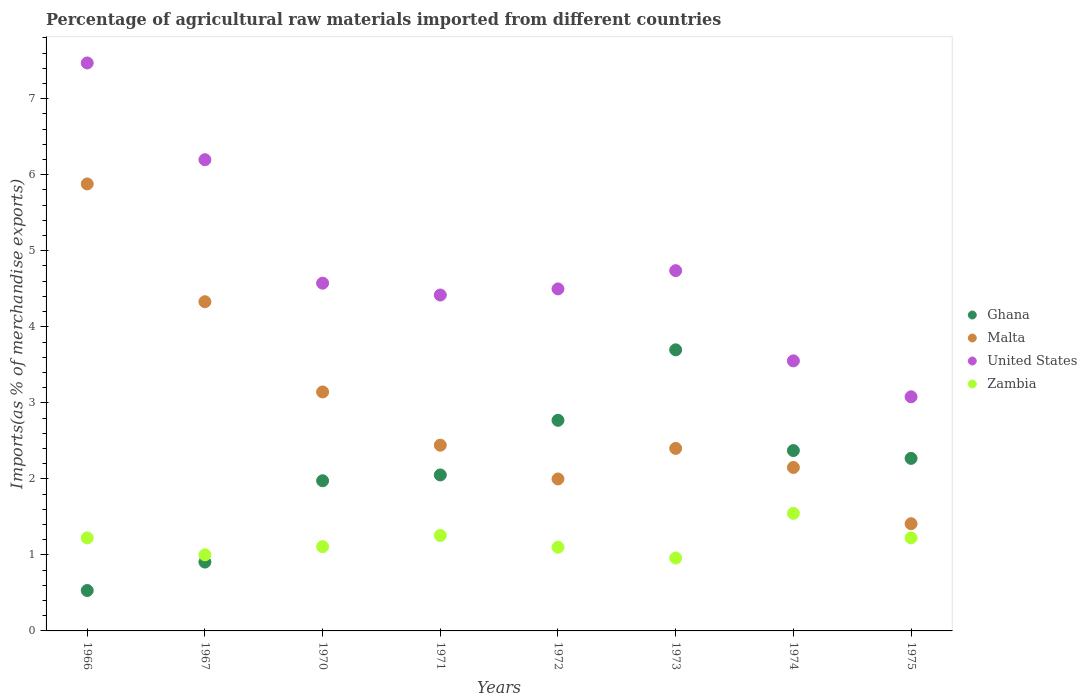How many different coloured dotlines are there?
Your response must be concise. 4. Is the number of dotlines equal to the number of legend labels?
Your answer should be compact. Yes. What is the percentage of imports to different countries in United States in 1970?
Provide a short and direct response. 4.57. Across all years, what is the maximum percentage of imports to different countries in Zambia?
Your answer should be very brief. 1.55. Across all years, what is the minimum percentage of imports to different countries in Malta?
Give a very brief answer. 1.41. In which year was the percentage of imports to different countries in Ghana maximum?
Give a very brief answer. 1973. In which year was the percentage of imports to different countries in Ghana minimum?
Offer a terse response. 1966. What is the total percentage of imports to different countries in Malta in the graph?
Make the answer very short. 23.75. What is the difference between the percentage of imports to different countries in Zambia in 1971 and that in 1974?
Your answer should be very brief. -0.29. What is the difference between the percentage of imports to different countries in Zambia in 1966 and the percentage of imports to different countries in Malta in 1972?
Provide a short and direct response. -0.78. What is the average percentage of imports to different countries in Malta per year?
Offer a very short reply. 2.97. In the year 1970, what is the difference between the percentage of imports to different countries in Malta and percentage of imports to different countries in Zambia?
Offer a very short reply. 2.03. In how many years, is the percentage of imports to different countries in Malta greater than 0.4 %?
Provide a succinct answer. 8. What is the ratio of the percentage of imports to different countries in Ghana in 1970 to that in 1973?
Keep it short and to the point. 0.53. What is the difference between the highest and the second highest percentage of imports to different countries in Zambia?
Your answer should be very brief. 0.29. What is the difference between the highest and the lowest percentage of imports to different countries in Ghana?
Offer a very short reply. 3.17. In how many years, is the percentage of imports to different countries in Ghana greater than the average percentage of imports to different countries in Ghana taken over all years?
Keep it short and to the point. 4. Is the sum of the percentage of imports to different countries in Zambia in 1973 and 1974 greater than the maximum percentage of imports to different countries in Malta across all years?
Keep it short and to the point. No. Is the percentage of imports to different countries in United States strictly greater than the percentage of imports to different countries in Malta over the years?
Your response must be concise. Yes. Are the values on the major ticks of Y-axis written in scientific E-notation?
Provide a succinct answer. No. Does the graph contain grids?
Make the answer very short. No. Where does the legend appear in the graph?
Keep it short and to the point. Center right. How many legend labels are there?
Make the answer very short. 4. What is the title of the graph?
Offer a terse response. Percentage of agricultural raw materials imported from different countries. What is the label or title of the X-axis?
Offer a very short reply. Years. What is the label or title of the Y-axis?
Ensure brevity in your answer.  Imports(as % of merchandise exports). What is the Imports(as % of merchandise exports) in Ghana in 1966?
Offer a terse response. 0.53. What is the Imports(as % of merchandise exports) in Malta in 1966?
Your response must be concise. 5.88. What is the Imports(as % of merchandise exports) of United States in 1966?
Your answer should be compact. 7.47. What is the Imports(as % of merchandise exports) in Zambia in 1966?
Provide a succinct answer. 1.22. What is the Imports(as % of merchandise exports) in Ghana in 1967?
Give a very brief answer. 0.91. What is the Imports(as % of merchandise exports) in Malta in 1967?
Make the answer very short. 4.33. What is the Imports(as % of merchandise exports) of United States in 1967?
Make the answer very short. 6.2. What is the Imports(as % of merchandise exports) in Zambia in 1967?
Offer a terse response. 1. What is the Imports(as % of merchandise exports) in Ghana in 1970?
Your answer should be compact. 1.98. What is the Imports(as % of merchandise exports) in Malta in 1970?
Provide a short and direct response. 3.14. What is the Imports(as % of merchandise exports) of United States in 1970?
Offer a terse response. 4.57. What is the Imports(as % of merchandise exports) in Zambia in 1970?
Your response must be concise. 1.11. What is the Imports(as % of merchandise exports) of Ghana in 1971?
Give a very brief answer. 2.05. What is the Imports(as % of merchandise exports) of Malta in 1971?
Your answer should be very brief. 2.44. What is the Imports(as % of merchandise exports) in United States in 1971?
Make the answer very short. 4.42. What is the Imports(as % of merchandise exports) in Zambia in 1971?
Provide a short and direct response. 1.26. What is the Imports(as % of merchandise exports) of Ghana in 1972?
Offer a terse response. 2.77. What is the Imports(as % of merchandise exports) in Malta in 1972?
Your response must be concise. 2. What is the Imports(as % of merchandise exports) in United States in 1972?
Provide a succinct answer. 4.5. What is the Imports(as % of merchandise exports) in Zambia in 1972?
Your answer should be compact. 1.1. What is the Imports(as % of merchandise exports) of Ghana in 1973?
Offer a terse response. 3.7. What is the Imports(as % of merchandise exports) in Malta in 1973?
Your answer should be very brief. 2.4. What is the Imports(as % of merchandise exports) in United States in 1973?
Provide a short and direct response. 4.74. What is the Imports(as % of merchandise exports) in Zambia in 1973?
Your response must be concise. 0.96. What is the Imports(as % of merchandise exports) of Ghana in 1974?
Your answer should be very brief. 2.37. What is the Imports(as % of merchandise exports) in Malta in 1974?
Offer a terse response. 2.15. What is the Imports(as % of merchandise exports) of United States in 1974?
Keep it short and to the point. 3.55. What is the Imports(as % of merchandise exports) in Zambia in 1974?
Give a very brief answer. 1.55. What is the Imports(as % of merchandise exports) of Ghana in 1975?
Provide a succinct answer. 2.27. What is the Imports(as % of merchandise exports) of Malta in 1975?
Keep it short and to the point. 1.41. What is the Imports(as % of merchandise exports) in United States in 1975?
Offer a very short reply. 3.08. What is the Imports(as % of merchandise exports) of Zambia in 1975?
Make the answer very short. 1.22. Across all years, what is the maximum Imports(as % of merchandise exports) in Ghana?
Offer a very short reply. 3.7. Across all years, what is the maximum Imports(as % of merchandise exports) of Malta?
Your response must be concise. 5.88. Across all years, what is the maximum Imports(as % of merchandise exports) of United States?
Your answer should be very brief. 7.47. Across all years, what is the maximum Imports(as % of merchandise exports) of Zambia?
Offer a terse response. 1.55. Across all years, what is the minimum Imports(as % of merchandise exports) of Ghana?
Provide a short and direct response. 0.53. Across all years, what is the minimum Imports(as % of merchandise exports) in Malta?
Give a very brief answer. 1.41. Across all years, what is the minimum Imports(as % of merchandise exports) of United States?
Offer a very short reply. 3.08. Across all years, what is the minimum Imports(as % of merchandise exports) in Zambia?
Your answer should be very brief. 0.96. What is the total Imports(as % of merchandise exports) in Ghana in the graph?
Provide a short and direct response. 16.57. What is the total Imports(as % of merchandise exports) of Malta in the graph?
Give a very brief answer. 23.75. What is the total Imports(as % of merchandise exports) in United States in the graph?
Your response must be concise. 38.53. What is the total Imports(as % of merchandise exports) of Zambia in the graph?
Your answer should be very brief. 9.42. What is the difference between the Imports(as % of merchandise exports) of Ghana in 1966 and that in 1967?
Provide a succinct answer. -0.37. What is the difference between the Imports(as % of merchandise exports) of Malta in 1966 and that in 1967?
Offer a terse response. 1.55. What is the difference between the Imports(as % of merchandise exports) in United States in 1966 and that in 1967?
Offer a terse response. 1.27. What is the difference between the Imports(as % of merchandise exports) of Zambia in 1966 and that in 1967?
Provide a succinct answer. 0.22. What is the difference between the Imports(as % of merchandise exports) in Ghana in 1966 and that in 1970?
Provide a short and direct response. -1.44. What is the difference between the Imports(as % of merchandise exports) in Malta in 1966 and that in 1970?
Offer a very short reply. 2.74. What is the difference between the Imports(as % of merchandise exports) in United States in 1966 and that in 1970?
Your answer should be very brief. 2.9. What is the difference between the Imports(as % of merchandise exports) in Zambia in 1966 and that in 1970?
Your answer should be compact. 0.11. What is the difference between the Imports(as % of merchandise exports) in Ghana in 1966 and that in 1971?
Ensure brevity in your answer.  -1.52. What is the difference between the Imports(as % of merchandise exports) of Malta in 1966 and that in 1971?
Keep it short and to the point. 3.44. What is the difference between the Imports(as % of merchandise exports) in United States in 1966 and that in 1971?
Offer a very short reply. 3.05. What is the difference between the Imports(as % of merchandise exports) in Zambia in 1966 and that in 1971?
Your answer should be very brief. -0.03. What is the difference between the Imports(as % of merchandise exports) of Ghana in 1966 and that in 1972?
Give a very brief answer. -2.24. What is the difference between the Imports(as % of merchandise exports) of Malta in 1966 and that in 1972?
Offer a very short reply. 3.88. What is the difference between the Imports(as % of merchandise exports) in United States in 1966 and that in 1972?
Keep it short and to the point. 2.97. What is the difference between the Imports(as % of merchandise exports) in Zambia in 1966 and that in 1972?
Offer a terse response. 0.12. What is the difference between the Imports(as % of merchandise exports) of Ghana in 1966 and that in 1973?
Provide a succinct answer. -3.17. What is the difference between the Imports(as % of merchandise exports) in Malta in 1966 and that in 1973?
Your answer should be compact. 3.48. What is the difference between the Imports(as % of merchandise exports) in United States in 1966 and that in 1973?
Offer a terse response. 2.73. What is the difference between the Imports(as % of merchandise exports) of Zambia in 1966 and that in 1973?
Keep it short and to the point. 0.26. What is the difference between the Imports(as % of merchandise exports) of Ghana in 1966 and that in 1974?
Offer a very short reply. -1.84. What is the difference between the Imports(as % of merchandise exports) of Malta in 1966 and that in 1974?
Make the answer very short. 3.73. What is the difference between the Imports(as % of merchandise exports) of United States in 1966 and that in 1974?
Offer a very short reply. 3.92. What is the difference between the Imports(as % of merchandise exports) of Zambia in 1966 and that in 1974?
Provide a short and direct response. -0.32. What is the difference between the Imports(as % of merchandise exports) of Ghana in 1966 and that in 1975?
Provide a succinct answer. -1.74. What is the difference between the Imports(as % of merchandise exports) in Malta in 1966 and that in 1975?
Your answer should be very brief. 4.47. What is the difference between the Imports(as % of merchandise exports) in United States in 1966 and that in 1975?
Ensure brevity in your answer.  4.39. What is the difference between the Imports(as % of merchandise exports) in Zambia in 1966 and that in 1975?
Give a very brief answer. -0. What is the difference between the Imports(as % of merchandise exports) of Ghana in 1967 and that in 1970?
Provide a short and direct response. -1.07. What is the difference between the Imports(as % of merchandise exports) in Malta in 1967 and that in 1970?
Offer a very short reply. 1.19. What is the difference between the Imports(as % of merchandise exports) in United States in 1967 and that in 1970?
Keep it short and to the point. 1.62. What is the difference between the Imports(as % of merchandise exports) of Zambia in 1967 and that in 1970?
Your answer should be very brief. -0.11. What is the difference between the Imports(as % of merchandise exports) of Ghana in 1967 and that in 1971?
Your answer should be very brief. -1.15. What is the difference between the Imports(as % of merchandise exports) in Malta in 1967 and that in 1971?
Give a very brief answer. 1.89. What is the difference between the Imports(as % of merchandise exports) in United States in 1967 and that in 1971?
Offer a very short reply. 1.78. What is the difference between the Imports(as % of merchandise exports) of Zambia in 1967 and that in 1971?
Give a very brief answer. -0.26. What is the difference between the Imports(as % of merchandise exports) of Ghana in 1967 and that in 1972?
Your answer should be compact. -1.86. What is the difference between the Imports(as % of merchandise exports) of Malta in 1967 and that in 1972?
Ensure brevity in your answer.  2.33. What is the difference between the Imports(as % of merchandise exports) of United States in 1967 and that in 1972?
Offer a very short reply. 1.7. What is the difference between the Imports(as % of merchandise exports) of Zambia in 1967 and that in 1972?
Keep it short and to the point. -0.1. What is the difference between the Imports(as % of merchandise exports) of Ghana in 1967 and that in 1973?
Your answer should be very brief. -2.79. What is the difference between the Imports(as % of merchandise exports) of Malta in 1967 and that in 1973?
Offer a very short reply. 1.93. What is the difference between the Imports(as % of merchandise exports) in United States in 1967 and that in 1973?
Provide a short and direct response. 1.46. What is the difference between the Imports(as % of merchandise exports) of Zambia in 1967 and that in 1973?
Your answer should be compact. 0.04. What is the difference between the Imports(as % of merchandise exports) of Ghana in 1967 and that in 1974?
Offer a very short reply. -1.47. What is the difference between the Imports(as % of merchandise exports) in Malta in 1967 and that in 1974?
Provide a succinct answer. 2.18. What is the difference between the Imports(as % of merchandise exports) in United States in 1967 and that in 1974?
Give a very brief answer. 2.65. What is the difference between the Imports(as % of merchandise exports) of Zambia in 1967 and that in 1974?
Make the answer very short. -0.55. What is the difference between the Imports(as % of merchandise exports) in Ghana in 1967 and that in 1975?
Give a very brief answer. -1.36. What is the difference between the Imports(as % of merchandise exports) in Malta in 1967 and that in 1975?
Provide a short and direct response. 2.92. What is the difference between the Imports(as % of merchandise exports) in United States in 1967 and that in 1975?
Make the answer very short. 3.12. What is the difference between the Imports(as % of merchandise exports) of Zambia in 1967 and that in 1975?
Give a very brief answer. -0.22. What is the difference between the Imports(as % of merchandise exports) of Ghana in 1970 and that in 1971?
Offer a terse response. -0.08. What is the difference between the Imports(as % of merchandise exports) of Malta in 1970 and that in 1971?
Ensure brevity in your answer.  0.7. What is the difference between the Imports(as % of merchandise exports) in United States in 1970 and that in 1971?
Your answer should be very brief. 0.16. What is the difference between the Imports(as % of merchandise exports) of Zambia in 1970 and that in 1971?
Your answer should be very brief. -0.15. What is the difference between the Imports(as % of merchandise exports) of Ghana in 1970 and that in 1972?
Offer a very short reply. -0.8. What is the difference between the Imports(as % of merchandise exports) in Malta in 1970 and that in 1972?
Your answer should be very brief. 1.14. What is the difference between the Imports(as % of merchandise exports) of United States in 1970 and that in 1972?
Keep it short and to the point. 0.08. What is the difference between the Imports(as % of merchandise exports) of Zambia in 1970 and that in 1972?
Offer a very short reply. 0.01. What is the difference between the Imports(as % of merchandise exports) of Ghana in 1970 and that in 1973?
Give a very brief answer. -1.72. What is the difference between the Imports(as % of merchandise exports) in Malta in 1970 and that in 1973?
Keep it short and to the point. 0.74. What is the difference between the Imports(as % of merchandise exports) of United States in 1970 and that in 1973?
Your answer should be compact. -0.16. What is the difference between the Imports(as % of merchandise exports) of Zambia in 1970 and that in 1973?
Offer a very short reply. 0.15. What is the difference between the Imports(as % of merchandise exports) in Ghana in 1970 and that in 1974?
Offer a very short reply. -0.4. What is the difference between the Imports(as % of merchandise exports) in Malta in 1970 and that in 1974?
Your answer should be compact. 0.99. What is the difference between the Imports(as % of merchandise exports) of United States in 1970 and that in 1974?
Make the answer very short. 1.02. What is the difference between the Imports(as % of merchandise exports) in Zambia in 1970 and that in 1974?
Keep it short and to the point. -0.44. What is the difference between the Imports(as % of merchandise exports) in Ghana in 1970 and that in 1975?
Offer a very short reply. -0.29. What is the difference between the Imports(as % of merchandise exports) in Malta in 1970 and that in 1975?
Offer a terse response. 1.73. What is the difference between the Imports(as % of merchandise exports) of United States in 1970 and that in 1975?
Make the answer very short. 1.49. What is the difference between the Imports(as % of merchandise exports) of Zambia in 1970 and that in 1975?
Your answer should be compact. -0.12. What is the difference between the Imports(as % of merchandise exports) of Ghana in 1971 and that in 1972?
Your answer should be very brief. -0.72. What is the difference between the Imports(as % of merchandise exports) of Malta in 1971 and that in 1972?
Offer a terse response. 0.44. What is the difference between the Imports(as % of merchandise exports) in United States in 1971 and that in 1972?
Your response must be concise. -0.08. What is the difference between the Imports(as % of merchandise exports) in Zambia in 1971 and that in 1972?
Your answer should be compact. 0.15. What is the difference between the Imports(as % of merchandise exports) in Ghana in 1971 and that in 1973?
Your answer should be very brief. -1.65. What is the difference between the Imports(as % of merchandise exports) of Malta in 1971 and that in 1973?
Provide a short and direct response. 0.04. What is the difference between the Imports(as % of merchandise exports) of United States in 1971 and that in 1973?
Offer a terse response. -0.32. What is the difference between the Imports(as % of merchandise exports) of Zambia in 1971 and that in 1973?
Provide a short and direct response. 0.3. What is the difference between the Imports(as % of merchandise exports) of Ghana in 1971 and that in 1974?
Ensure brevity in your answer.  -0.32. What is the difference between the Imports(as % of merchandise exports) in Malta in 1971 and that in 1974?
Provide a short and direct response. 0.29. What is the difference between the Imports(as % of merchandise exports) of United States in 1971 and that in 1974?
Provide a succinct answer. 0.87. What is the difference between the Imports(as % of merchandise exports) in Zambia in 1971 and that in 1974?
Your answer should be very brief. -0.29. What is the difference between the Imports(as % of merchandise exports) in Ghana in 1971 and that in 1975?
Give a very brief answer. -0.22. What is the difference between the Imports(as % of merchandise exports) of Malta in 1971 and that in 1975?
Make the answer very short. 1.03. What is the difference between the Imports(as % of merchandise exports) of United States in 1971 and that in 1975?
Ensure brevity in your answer.  1.34. What is the difference between the Imports(as % of merchandise exports) of Zambia in 1971 and that in 1975?
Your answer should be compact. 0.03. What is the difference between the Imports(as % of merchandise exports) in Ghana in 1972 and that in 1973?
Give a very brief answer. -0.93. What is the difference between the Imports(as % of merchandise exports) of Malta in 1972 and that in 1973?
Provide a succinct answer. -0.4. What is the difference between the Imports(as % of merchandise exports) in United States in 1972 and that in 1973?
Give a very brief answer. -0.24. What is the difference between the Imports(as % of merchandise exports) in Zambia in 1972 and that in 1973?
Offer a terse response. 0.14. What is the difference between the Imports(as % of merchandise exports) in Ghana in 1972 and that in 1974?
Keep it short and to the point. 0.4. What is the difference between the Imports(as % of merchandise exports) in Malta in 1972 and that in 1974?
Give a very brief answer. -0.15. What is the difference between the Imports(as % of merchandise exports) in United States in 1972 and that in 1974?
Your response must be concise. 0.95. What is the difference between the Imports(as % of merchandise exports) of Zambia in 1972 and that in 1974?
Offer a terse response. -0.45. What is the difference between the Imports(as % of merchandise exports) in Ghana in 1972 and that in 1975?
Keep it short and to the point. 0.5. What is the difference between the Imports(as % of merchandise exports) of Malta in 1972 and that in 1975?
Make the answer very short. 0.59. What is the difference between the Imports(as % of merchandise exports) of United States in 1972 and that in 1975?
Ensure brevity in your answer.  1.42. What is the difference between the Imports(as % of merchandise exports) in Zambia in 1972 and that in 1975?
Give a very brief answer. -0.12. What is the difference between the Imports(as % of merchandise exports) of Ghana in 1973 and that in 1974?
Your answer should be compact. 1.32. What is the difference between the Imports(as % of merchandise exports) in Malta in 1973 and that in 1974?
Your answer should be compact. 0.25. What is the difference between the Imports(as % of merchandise exports) of United States in 1973 and that in 1974?
Keep it short and to the point. 1.19. What is the difference between the Imports(as % of merchandise exports) of Zambia in 1973 and that in 1974?
Ensure brevity in your answer.  -0.59. What is the difference between the Imports(as % of merchandise exports) of Ghana in 1973 and that in 1975?
Offer a very short reply. 1.43. What is the difference between the Imports(as % of merchandise exports) in Malta in 1973 and that in 1975?
Provide a succinct answer. 0.99. What is the difference between the Imports(as % of merchandise exports) of United States in 1973 and that in 1975?
Provide a succinct answer. 1.66. What is the difference between the Imports(as % of merchandise exports) in Zambia in 1973 and that in 1975?
Your answer should be compact. -0.27. What is the difference between the Imports(as % of merchandise exports) in Ghana in 1974 and that in 1975?
Ensure brevity in your answer.  0.1. What is the difference between the Imports(as % of merchandise exports) in Malta in 1974 and that in 1975?
Ensure brevity in your answer.  0.74. What is the difference between the Imports(as % of merchandise exports) of United States in 1974 and that in 1975?
Give a very brief answer. 0.47. What is the difference between the Imports(as % of merchandise exports) of Zambia in 1974 and that in 1975?
Ensure brevity in your answer.  0.32. What is the difference between the Imports(as % of merchandise exports) in Ghana in 1966 and the Imports(as % of merchandise exports) in Malta in 1967?
Offer a terse response. -3.8. What is the difference between the Imports(as % of merchandise exports) in Ghana in 1966 and the Imports(as % of merchandise exports) in United States in 1967?
Your answer should be compact. -5.67. What is the difference between the Imports(as % of merchandise exports) in Ghana in 1966 and the Imports(as % of merchandise exports) in Zambia in 1967?
Keep it short and to the point. -0.47. What is the difference between the Imports(as % of merchandise exports) in Malta in 1966 and the Imports(as % of merchandise exports) in United States in 1967?
Ensure brevity in your answer.  -0.32. What is the difference between the Imports(as % of merchandise exports) in Malta in 1966 and the Imports(as % of merchandise exports) in Zambia in 1967?
Your answer should be compact. 4.88. What is the difference between the Imports(as % of merchandise exports) in United States in 1966 and the Imports(as % of merchandise exports) in Zambia in 1967?
Give a very brief answer. 6.47. What is the difference between the Imports(as % of merchandise exports) in Ghana in 1966 and the Imports(as % of merchandise exports) in Malta in 1970?
Make the answer very short. -2.61. What is the difference between the Imports(as % of merchandise exports) in Ghana in 1966 and the Imports(as % of merchandise exports) in United States in 1970?
Provide a succinct answer. -4.04. What is the difference between the Imports(as % of merchandise exports) in Ghana in 1966 and the Imports(as % of merchandise exports) in Zambia in 1970?
Provide a succinct answer. -0.58. What is the difference between the Imports(as % of merchandise exports) in Malta in 1966 and the Imports(as % of merchandise exports) in United States in 1970?
Your answer should be compact. 1.31. What is the difference between the Imports(as % of merchandise exports) of Malta in 1966 and the Imports(as % of merchandise exports) of Zambia in 1970?
Make the answer very short. 4.77. What is the difference between the Imports(as % of merchandise exports) in United States in 1966 and the Imports(as % of merchandise exports) in Zambia in 1970?
Ensure brevity in your answer.  6.36. What is the difference between the Imports(as % of merchandise exports) of Ghana in 1966 and the Imports(as % of merchandise exports) of Malta in 1971?
Provide a succinct answer. -1.91. What is the difference between the Imports(as % of merchandise exports) in Ghana in 1966 and the Imports(as % of merchandise exports) in United States in 1971?
Offer a terse response. -3.89. What is the difference between the Imports(as % of merchandise exports) of Ghana in 1966 and the Imports(as % of merchandise exports) of Zambia in 1971?
Ensure brevity in your answer.  -0.72. What is the difference between the Imports(as % of merchandise exports) of Malta in 1966 and the Imports(as % of merchandise exports) of United States in 1971?
Keep it short and to the point. 1.46. What is the difference between the Imports(as % of merchandise exports) in Malta in 1966 and the Imports(as % of merchandise exports) in Zambia in 1971?
Provide a short and direct response. 4.62. What is the difference between the Imports(as % of merchandise exports) of United States in 1966 and the Imports(as % of merchandise exports) of Zambia in 1971?
Give a very brief answer. 6.21. What is the difference between the Imports(as % of merchandise exports) of Ghana in 1966 and the Imports(as % of merchandise exports) of Malta in 1972?
Ensure brevity in your answer.  -1.47. What is the difference between the Imports(as % of merchandise exports) of Ghana in 1966 and the Imports(as % of merchandise exports) of United States in 1972?
Keep it short and to the point. -3.97. What is the difference between the Imports(as % of merchandise exports) in Ghana in 1966 and the Imports(as % of merchandise exports) in Zambia in 1972?
Provide a short and direct response. -0.57. What is the difference between the Imports(as % of merchandise exports) of Malta in 1966 and the Imports(as % of merchandise exports) of United States in 1972?
Your response must be concise. 1.38. What is the difference between the Imports(as % of merchandise exports) of Malta in 1966 and the Imports(as % of merchandise exports) of Zambia in 1972?
Make the answer very short. 4.78. What is the difference between the Imports(as % of merchandise exports) of United States in 1966 and the Imports(as % of merchandise exports) of Zambia in 1972?
Offer a terse response. 6.37. What is the difference between the Imports(as % of merchandise exports) of Ghana in 1966 and the Imports(as % of merchandise exports) of Malta in 1973?
Offer a very short reply. -1.87. What is the difference between the Imports(as % of merchandise exports) in Ghana in 1966 and the Imports(as % of merchandise exports) in United States in 1973?
Your response must be concise. -4.21. What is the difference between the Imports(as % of merchandise exports) of Ghana in 1966 and the Imports(as % of merchandise exports) of Zambia in 1973?
Give a very brief answer. -0.43. What is the difference between the Imports(as % of merchandise exports) in Malta in 1966 and the Imports(as % of merchandise exports) in United States in 1973?
Provide a succinct answer. 1.14. What is the difference between the Imports(as % of merchandise exports) of Malta in 1966 and the Imports(as % of merchandise exports) of Zambia in 1973?
Your response must be concise. 4.92. What is the difference between the Imports(as % of merchandise exports) in United States in 1966 and the Imports(as % of merchandise exports) in Zambia in 1973?
Offer a terse response. 6.51. What is the difference between the Imports(as % of merchandise exports) in Ghana in 1966 and the Imports(as % of merchandise exports) in Malta in 1974?
Your answer should be compact. -1.62. What is the difference between the Imports(as % of merchandise exports) in Ghana in 1966 and the Imports(as % of merchandise exports) in United States in 1974?
Your response must be concise. -3.02. What is the difference between the Imports(as % of merchandise exports) of Ghana in 1966 and the Imports(as % of merchandise exports) of Zambia in 1974?
Ensure brevity in your answer.  -1.01. What is the difference between the Imports(as % of merchandise exports) of Malta in 1966 and the Imports(as % of merchandise exports) of United States in 1974?
Your answer should be very brief. 2.33. What is the difference between the Imports(as % of merchandise exports) in Malta in 1966 and the Imports(as % of merchandise exports) in Zambia in 1974?
Offer a terse response. 4.33. What is the difference between the Imports(as % of merchandise exports) in United States in 1966 and the Imports(as % of merchandise exports) in Zambia in 1974?
Provide a succinct answer. 5.92. What is the difference between the Imports(as % of merchandise exports) in Ghana in 1966 and the Imports(as % of merchandise exports) in Malta in 1975?
Offer a terse response. -0.88. What is the difference between the Imports(as % of merchandise exports) of Ghana in 1966 and the Imports(as % of merchandise exports) of United States in 1975?
Your answer should be compact. -2.55. What is the difference between the Imports(as % of merchandise exports) of Ghana in 1966 and the Imports(as % of merchandise exports) of Zambia in 1975?
Keep it short and to the point. -0.69. What is the difference between the Imports(as % of merchandise exports) in Malta in 1966 and the Imports(as % of merchandise exports) in United States in 1975?
Keep it short and to the point. 2.8. What is the difference between the Imports(as % of merchandise exports) of Malta in 1966 and the Imports(as % of merchandise exports) of Zambia in 1975?
Your answer should be very brief. 4.65. What is the difference between the Imports(as % of merchandise exports) in United States in 1966 and the Imports(as % of merchandise exports) in Zambia in 1975?
Your answer should be very brief. 6.25. What is the difference between the Imports(as % of merchandise exports) of Ghana in 1967 and the Imports(as % of merchandise exports) of Malta in 1970?
Provide a succinct answer. -2.24. What is the difference between the Imports(as % of merchandise exports) in Ghana in 1967 and the Imports(as % of merchandise exports) in United States in 1970?
Keep it short and to the point. -3.67. What is the difference between the Imports(as % of merchandise exports) in Ghana in 1967 and the Imports(as % of merchandise exports) in Zambia in 1970?
Give a very brief answer. -0.2. What is the difference between the Imports(as % of merchandise exports) in Malta in 1967 and the Imports(as % of merchandise exports) in United States in 1970?
Give a very brief answer. -0.24. What is the difference between the Imports(as % of merchandise exports) of Malta in 1967 and the Imports(as % of merchandise exports) of Zambia in 1970?
Your response must be concise. 3.22. What is the difference between the Imports(as % of merchandise exports) of United States in 1967 and the Imports(as % of merchandise exports) of Zambia in 1970?
Your response must be concise. 5.09. What is the difference between the Imports(as % of merchandise exports) in Ghana in 1967 and the Imports(as % of merchandise exports) in Malta in 1971?
Keep it short and to the point. -1.54. What is the difference between the Imports(as % of merchandise exports) in Ghana in 1967 and the Imports(as % of merchandise exports) in United States in 1971?
Your answer should be compact. -3.51. What is the difference between the Imports(as % of merchandise exports) in Ghana in 1967 and the Imports(as % of merchandise exports) in Zambia in 1971?
Offer a very short reply. -0.35. What is the difference between the Imports(as % of merchandise exports) in Malta in 1967 and the Imports(as % of merchandise exports) in United States in 1971?
Offer a very short reply. -0.09. What is the difference between the Imports(as % of merchandise exports) of Malta in 1967 and the Imports(as % of merchandise exports) of Zambia in 1971?
Keep it short and to the point. 3.07. What is the difference between the Imports(as % of merchandise exports) of United States in 1967 and the Imports(as % of merchandise exports) of Zambia in 1971?
Keep it short and to the point. 4.94. What is the difference between the Imports(as % of merchandise exports) in Ghana in 1967 and the Imports(as % of merchandise exports) in Malta in 1972?
Offer a terse response. -1.09. What is the difference between the Imports(as % of merchandise exports) in Ghana in 1967 and the Imports(as % of merchandise exports) in United States in 1972?
Provide a short and direct response. -3.59. What is the difference between the Imports(as % of merchandise exports) of Ghana in 1967 and the Imports(as % of merchandise exports) of Zambia in 1972?
Keep it short and to the point. -0.2. What is the difference between the Imports(as % of merchandise exports) of Malta in 1967 and the Imports(as % of merchandise exports) of United States in 1972?
Provide a succinct answer. -0.17. What is the difference between the Imports(as % of merchandise exports) in Malta in 1967 and the Imports(as % of merchandise exports) in Zambia in 1972?
Your answer should be very brief. 3.23. What is the difference between the Imports(as % of merchandise exports) of United States in 1967 and the Imports(as % of merchandise exports) of Zambia in 1972?
Your response must be concise. 5.1. What is the difference between the Imports(as % of merchandise exports) of Ghana in 1967 and the Imports(as % of merchandise exports) of Malta in 1973?
Keep it short and to the point. -1.49. What is the difference between the Imports(as % of merchandise exports) in Ghana in 1967 and the Imports(as % of merchandise exports) in United States in 1973?
Keep it short and to the point. -3.83. What is the difference between the Imports(as % of merchandise exports) in Ghana in 1967 and the Imports(as % of merchandise exports) in Zambia in 1973?
Make the answer very short. -0.05. What is the difference between the Imports(as % of merchandise exports) in Malta in 1967 and the Imports(as % of merchandise exports) in United States in 1973?
Provide a succinct answer. -0.41. What is the difference between the Imports(as % of merchandise exports) in Malta in 1967 and the Imports(as % of merchandise exports) in Zambia in 1973?
Provide a succinct answer. 3.37. What is the difference between the Imports(as % of merchandise exports) in United States in 1967 and the Imports(as % of merchandise exports) in Zambia in 1973?
Keep it short and to the point. 5.24. What is the difference between the Imports(as % of merchandise exports) in Ghana in 1967 and the Imports(as % of merchandise exports) in Malta in 1974?
Ensure brevity in your answer.  -1.24. What is the difference between the Imports(as % of merchandise exports) in Ghana in 1967 and the Imports(as % of merchandise exports) in United States in 1974?
Offer a very short reply. -2.65. What is the difference between the Imports(as % of merchandise exports) of Ghana in 1967 and the Imports(as % of merchandise exports) of Zambia in 1974?
Offer a terse response. -0.64. What is the difference between the Imports(as % of merchandise exports) of Malta in 1967 and the Imports(as % of merchandise exports) of Zambia in 1974?
Your response must be concise. 2.78. What is the difference between the Imports(as % of merchandise exports) of United States in 1967 and the Imports(as % of merchandise exports) of Zambia in 1974?
Give a very brief answer. 4.65. What is the difference between the Imports(as % of merchandise exports) in Ghana in 1967 and the Imports(as % of merchandise exports) in Malta in 1975?
Offer a very short reply. -0.5. What is the difference between the Imports(as % of merchandise exports) of Ghana in 1967 and the Imports(as % of merchandise exports) of United States in 1975?
Your response must be concise. -2.17. What is the difference between the Imports(as % of merchandise exports) in Ghana in 1967 and the Imports(as % of merchandise exports) in Zambia in 1975?
Offer a very short reply. -0.32. What is the difference between the Imports(as % of merchandise exports) of Malta in 1967 and the Imports(as % of merchandise exports) of United States in 1975?
Keep it short and to the point. 1.25. What is the difference between the Imports(as % of merchandise exports) in Malta in 1967 and the Imports(as % of merchandise exports) in Zambia in 1975?
Make the answer very short. 3.11. What is the difference between the Imports(as % of merchandise exports) of United States in 1967 and the Imports(as % of merchandise exports) of Zambia in 1975?
Provide a succinct answer. 4.97. What is the difference between the Imports(as % of merchandise exports) of Ghana in 1970 and the Imports(as % of merchandise exports) of Malta in 1971?
Provide a short and direct response. -0.47. What is the difference between the Imports(as % of merchandise exports) of Ghana in 1970 and the Imports(as % of merchandise exports) of United States in 1971?
Give a very brief answer. -2.44. What is the difference between the Imports(as % of merchandise exports) in Ghana in 1970 and the Imports(as % of merchandise exports) in Zambia in 1971?
Offer a terse response. 0.72. What is the difference between the Imports(as % of merchandise exports) in Malta in 1970 and the Imports(as % of merchandise exports) in United States in 1971?
Your answer should be compact. -1.27. What is the difference between the Imports(as % of merchandise exports) of Malta in 1970 and the Imports(as % of merchandise exports) of Zambia in 1971?
Offer a terse response. 1.89. What is the difference between the Imports(as % of merchandise exports) in United States in 1970 and the Imports(as % of merchandise exports) in Zambia in 1971?
Offer a terse response. 3.32. What is the difference between the Imports(as % of merchandise exports) in Ghana in 1970 and the Imports(as % of merchandise exports) in Malta in 1972?
Your response must be concise. -0.02. What is the difference between the Imports(as % of merchandise exports) of Ghana in 1970 and the Imports(as % of merchandise exports) of United States in 1972?
Provide a succinct answer. -2.52. What is the difference between the Imports(as % of merchandise exports) of Ghana in 1970 and the Imports(as % of merchandise exports) of Zambia in 1972?
Offer a very short reply. 0.87. What is the difference between the Imports(as % of merchandise exports) of Malta in 1970 and the Imports(as % of merchandise exports) of United States in 1972?
Your answer should be very brief. -1.36. What is the difference between the Imports(as % of merchandise exports) of Malta in 1970 and the Imports(as % of merchandise exports) of Zambia in 1972?
Give a very brief answer. 2.04. What is the difference between the Imports(as % of merchandise exports) of United States in 1970 and the Imports(as % of merchandise exports) of Zambia in 1972?
Make the answer very short. 3.47. What is the difference between the Imports(as % of merchandise exports) of Ghana in 1970 and the Imports(as % of merchandise exports) of Malta in 1973?
Your answer should be compact. -0.43. What is the difference between the Imports(as % of merchandise exports) of Ghana in 1970 and the Imports(as % of merchandise exports) of United States in 1973?
Give a very brief answer. -2.76. What is the difference between the Imports(as % of merchandise exports) in Ghana in 1970 and the Imports(as % of merchandise exports) in Zambia in 1973?
Make the answer very short. 1.02. What is the difference between the Imports(as % of merchandise exports) of Malta in 1970 and the Imports(as % of merchandise exports) of United States in 1973?
Your answer should be very brief. -1.6. What is the difference between the Imports(as % of merchandise exports) of Malta in 1970 and the Imports(as % of merchandise exports) of Zambia in 1973?
Make the answer very short. 2.18. What is the difference between the Imports(as % of merchandise exports) of United States in 1970 and the Imports(as % of merchandise exports) of Zambia in 1973?
Offer a terse response. 3.62. What is the difference between the Imports(as % of merchandise exports) of Ghana in 1970 and the Imports(as % of merchandise exports) of Malta in 1974?
Offer a very short reply. -0.17. What is the difference between the Imports(as % of merchandise exports) in Ghana in 1970 and the Imports(as % of merchandise exports) in United States in 1974?
Ensure brevity in your answer.  -1.58. What is the difference between the Imports(as % of merchandise exports) in Ghana in 1970 and the Imports(as % of merchandise exports) in Zambia in 1974?
Provide a succinct answer. 0.43. What is the difference between the Imports(as % of merchandise exports) in Malta in 1970 and the Imports(as % of merchandise exports) in United States in 1974?
Make the answer very short. -0.41. What is the difference between the Imports(as % of merchandise exports) in Malta in 1970 and the Imports(as % of merchandise exports) in Zambia in 1974?
Provide a short and direct response. 1.6. What is the difference between the Imports(as % of merchandise exports) of United States in 1970 and the Imports(as % of merchandise exports) of Zambia in 1974?
Make the answer very short. 3.03. What is the difference between the Imports(as % of merchandise exports) in Ghana in 1970 and the Imports(as % of merchandise exports) in Malta in 1975?
Offer a terse response. 0.56. What is the difference between the Imports(as % of merchandise exports) in Ghana in 1970 and the Imports(as % of merchandise exports) in United States in 1975?
Make the answer very short. -1.1. What is the difference between the Imports(as % of merchandise exports) of Ghana in 1970 and the Imports(as % of merchandise exports) of Zambia in 1975?
Offer a terse response. 0.75. What is the difference between the Imports(as % of merchandise exports) in Malta in 1970 and the Imports(as % of merchandise exports) in United States in 1975?
Give a very brief answer. 0.06. What is the difference between the Imports(as % of merchandise exports) of Malta in 1970 and the Imports(as % of merchandise exports) of Zambia in 1975?
Offer a very short reply. 1.92. What is the difference between the Imports(as % of merchandise exports) of United States in 1970 and the Imports(as % of merchandise exports) of Zambia in 1975?
Make the answer very short. 3.35. What is the difference between the Imports(as % of merchandise exports) in Ghana in 1971 and the Imports(as % of merchandise exports) in Malta in 1972?
Provide a succinct answer. 0.05. What is the difference between the Imports(as % of merchandise exports) in Ghana in 1971 and the Imports(as % of merchandise exports) in United States in 1972?
Make the answer very short. -2.45. What is the difference between the Imports(as % of merchandise exports) in Ghana in 1971 and the Imports(as % of merchandise exports) in Zambia in 1972?
Make the answer very short. 0.95. What is the difference between the Imports(as % of merchandise exports) of Malta in 1971 and the Imports(as % of merchandise exports) of United States in 1972?
Provide a short and direct response. -2.06. What is the difference between the Imports(as % of merchandise exports) of Malta in 1971 and the Imports(as % of merchandise exports) of Zambia in 1972?
Make the answer very short. 1.34. What is the difference between the Imports(as % of merchandise exports) of United States in 1971 and the Imports(as % of merchandise exports) of Zambia in 1972?
Give a very brief answer. 3.32. What is the difference between the Imports(as % of merchandise exports) in Ghana in 1971 and the Imports(as % of merchandise exports) in Malta in 1973?
Your answer should be very brief. -0.35. What is the difference between the Imports(as % of merchandise exports) of Ghana in 1971 and the Imports(as % of merchandise exports) of United States in 1973?
Give a very brief answer. -2.69. What is the difference between the Imports(as % of merchandise exports) in Ghana in 1971 and the Imports(as % of merchandise exports) in Zambia in 1973?
Provide a succinct answer. 1.09. What is the difference between the Imports(as % of merchandise exports) in Malta in 1971 and the Imports(as % of merchandise exports) in United States in 1973?
Provide a short and direct response. -2.3. What is the difference between the Imports(as % of merchandise exports) in Malta in 1971 and the Imports(as % of merchandise exports) in Zambia in 1973?
Your answer should be compact. 1.48. What is the difference between the Imports(as % of merchandise exports) of United States in 1971 and the Imports(as % of merchandise exports) of Zambia in 1973?
Offer a very short reply. 3.46. What is the difference between the Imports(as % of merchandise exports) in Ghana in 1971 and the Imports(as % of merchandise exports) in Malta in 1974?
Give a very brief answer. -0.1. What is the difference between the Imports(as % of merchandise exports) of Ghana in 1971 and the Imports(as % of merchandise exports) of United States in 1974?
Your answer should be very brief. -1.5. What is the difference between the Imports(as % of merchandise exports) of Ghana in 1971 and the Imports(as % of merchandise exports) of Zambia in 1974?
Offer a terse response. 0.5. What is the difference between the Imports(as % of merchandise exports) in Malta in 1971 and the Imports(as % of merchandise exports) in United States in 1974?
Provide a short and direct response. -1.11. What is the difference between the Imports(as % of merchandise exports) in Malta in 1971 and the Imports(as % of merchandise exports) in Zambia in 1974?
Give a very brief answer. 0.9. What is the difference between the Imports(as % of merchandise exports) of United States in 1971 and the Imports(as % of merchandise exports) of Zambia in 1974?
Give a very brief answer. 2.87. What is the difference between the Imports(as % of merchandise exports) in Ghana in 1971 and the Imports(as % of merchandise exports) in Malta in 1975?
Give a very brief answer. 0.64. What is the difference between the Imports(as % of merchandise exports) of Ghana in 1971 and the Imports(as % of merchandise exports) of United States in 1975?
Keep it short and to the point. -1.03. What is the difference between the Imports(as % of merchandise exports) in Ghana in 1971 and the Imports(as % of merchandise exports) in Zambia in 1975?
Ensure brevity in your answer.  0.83. What is the difference between the Imports(as % of merchandise exports) of Malta in 1971 and the Imports(as % of merchandise exports) of United States in 1975?
Offer a terse response. -0.64. What is the difference between the Imports(as % of merchandise exports) of Malta in 1971 and the Imports(as % of merchandise exports) of Zambia in 1975?
Offer a very short reply. 1.22. What is the difference between the Imports(as % of merchandise exports) of United States in 1971 and the Imports(as % of merchandise exports) of Zambia in 1975?
Ensure brevity in your answer.  3.19. What is the difference between the Imports(as % of merchandise exports) in Ghana in 1972 and the Imports(as % of merchandise exports) in Malta in 1973?
Provide a succinct answer. 0.37. What is the difference between the Imports(as % of merchandise exports) in Ghana in 1972 and the Imports(as % of merchandise exports) in United States in 1973?
Your response must be concise. -1.97. What is the difference between the Imports(as % of merchandise exports) in Ghana in 1972 and the Imports(as % of merchandise exports) in Zambia in 1973?
Give a very brief answer. 1.81. What is the difference between the Imports(as % of merchandise exports) of Malta in 1972 and the Imports(as % of merchandise exports) of United States in 1973?
Provide a short and direct response. -2.74. What is the difference between the Imports(as % of merchandise exports) in Malta in 1972 and the Imports(as % of merchandise exports) in Zambia in 1973?
Your response must be concise. 1.04. What is the difference between the Imports(as % of merchandise exports) of United States in 1972 and the Imports(as % of merchandise exports) of Zambia in 1973?
Offer a terse response. 3.54. What is the difference between the Imports(as % of merchandise exports) of Ghana in 1972 and the Imports(as % of merchandise exports) of Malta in 1974?
Make the answer very short. 0.62. What is the difference between the Imports(as % of merchandise exports) of Ghana in 1972 and the Imports(as % of merchandise exports) of United States in 1974?
Your response must be concise. -0.78. What is the difference between the Imports(as % of merchandise exports) in Ghana in 1972 and the Imports(as % of merchandise exports) in Zambia in 1974?
Provide a succinct answer. 1.22. What is the difference between the Imports(as % of merchandise exports) of Malta in 1972 and the Imports(as % of merchandise exports) of United States in 1974?
Your response must be concise. -1.55. What is the difference between the Imports(as % of merchandise exports) in Malta in 1972 and the Imports(as % of merchandise exports) in Zambia in 1974?
Keep it short and to the point. 0.45. What is the difference between the Imports(as % of merchandise exports) of United States in 1972 and the Imports(as % of merchandise exports) of Zambia in 1974?
Give a very brief answer. 2.95. What is the difference between the Imports(as % of merchandise exports) in Ghana in 1972 and the Imports(as % of merchandise exports) in Malta in 1975?
Offer a very short reply. 1.36. What is the difference between the Imports(as % of merchandise exports) of Ghana in 1972 and the Imports(as % of merchandise exports) of United States in 1975?
Your answer should be very brief. -0.31. What is the difference between the Imports(as % of merchandise exports) in Ghana in 1972 and the Imports(as % of merchandise exports) in Zambia in 1975?
Your answer should be very brief. 1.55. What is the difference between the Imports(as % of merchandise exports) in Malta in 1972 and the Imports(as % of merchandise exports) in United States in 1975?
Give a very brief answer. -1.08. What is the difference between the Imports(as % of merchandise exports) in Malta in 1972 and the Imports(as % of merchandise exports) in Zambia in 1975?
Keep it short and to the point. 0.77. What is the difference between the Imports(as % of merchandise exports) in United States in 1972 and the Imports(as % of merchandise exports) in Zambia in 1975?
Your answer should be very brief. 3.27. What is the difference between the Imports(as % of merchandise exports) in Ghana in 1973 and the Imports(as % of merchandise exports) in Malta in 1974?
Your answer should be compact. 1.55. What is the difference between the Imports(as % of merchandise exports) of Ghana in 1973 and the Imports(as % of merchandise exports) of United States in 1974?
Provide a short and direct response. 0.15. What is the difference between the Imports(as % of merchandise exports) of Ghana in 1973 and the Imports(as % of merchandise exports) of Zambia in 1974?
Your response must be concise. 2.15. What is the difference between the Imports(as % of merchandise exports) of Malta in 1973 and the Imports(as % of merchandise exports) of United States in 1974?
Offer a terse response. -1.15. What is the difference between the Imports(as % of merchandise exports) of Malta in 1973 and the Imports(as % of merchandise exports) of Zambia in 1974?
Make the answer very short. 0.85. What is the difference between the Imports(as % of merchandise exports) of United States in 1973 and the Imports(as % of merchandise exports) of Zambia in 1974?
Your answer should be compact. 3.19. What is the difference between the Imports(as % of merchandise exports) in Ghana in 1973 and the Imports(as % of merchandise exports) in Malta in 1975?
Offer a very short reply. 2.29. What is the difference between the Imports(as % of merchandise exports) in Ghana in 1973 and the Imports(as % of merchandise exports) in United States in 1975?
Make the answer very short. 0.62. What is the difference between the Imports(as % of merchandise exports) of Ghana in 1973 and the Imports(as % of merchandise exports) of Zambia in 1975?
Ensure brevity in your answer.  2.47. What is the difference between the Imports(as % of merchandise exports) in Malta in 1973 and the Imports(as % of merchandise exports) in United States in 1975?
Provide a succinct answer. -0.68. What is the difference between the Imports(as % of merchandise exports) of Malta in 1973 and the Imports(as % of merchandise exports) of Zambia in 1975?
Provide a succinct answer. 1.18. What is the difference between the Imports(as % of merchandise exports) in United States in 1973 and the Imports(as % of merchandise exports) in Zambia in 1975?
Provide a succinct answer. 3.51. What is the difference between the Imports(as % of merchandise exports) of Ghana in 1974 and the Imports(as % of merchandise exports) of Malta in 1975?
Offer a terse response. 0.96. What is the difference between the Imports(as % of merchandise exports) in Ghana in 1974 and the Imports(as % of merchandise exports) in United States in 1975?
Offer a terse response. -0.71. What is the difference between the Imports(as % of merchandise exports) of Ghana in 1974 and the Imports(as % of merchandise exports) of Zambia in 1975?
Ensure brevity in your answer.  1.15. What is the difference between the Imports(as % of merchandise exports) of Malta in 1974 and the Imports(as % of merchandise exports) of United States in 1975?
Provide a succinct answer. -0.93. What is the difference between the Imports(as % of merchandise exports) in Malta in 1974 and the Imports(as % of merchandise exports) in Zambia in 1975?
Offer a terse response. 0.93. What is the difference between the Imports(as % of merchandise exports) of United States in 1974 and the Imports(as % of merchandise exports) of Zambia in 1975?
Your answer should be very brief. 2.33. What is the average Imports(as % of merchandise exports) in Ghana per year?
Ensure brevity in your answer.  2.07. What is the average Imports(as % of merchandise exports) in Malta per year?
Keep it short and to the point. 2.97. What is the average Imports(as % of merchandise exports) of United States per year?
Make the answer very short. 4.82. What is the average Imports(as % of merchandise exports) in Zambia per year?
Provide a succinct answer. 1.18. In the year 1966, what is the difference between the Imports(as % of merchandise exports) in Ghana and Imports(as % of merchandise exports) in Malta?
Offer a very short reply. -5.35. In the year 1966, what is the difference between the Imports(as % of merchandise exports) of Ghana and Imports(as % of merchandise exports) of United States?
Offer a terse response. -6.94. In the year 1966, what is the difference between the Imports(as % of merchandise exports) in Ghana and Imports(as % of merchandise exports) in Zambia?
Keep it short and to the point. -0.69. In the year 1966, what is the difference between the Imports(as % of merchandise exports) in Malta and Imports(as % of merchandise exports) in United States?
Give a very brief answer. -1.59. In the year 1966, what is the difference between the Imports(as % of merchandise exports) in Malta and Imports(as % of merchandise exports) in Zambia?
Offer a terse response. 4.66. In the year 1966, what is the difference between the Imports(as % of merchandise exports) of United States and Imports(as % of merchandise exports) of Zambia?
Provide a short and direct response. 6.25. In the year 1967, what is the difference between the Imports(as % of merchandise exports) of Ghana and Imports(as % of merchandise exports) of Malta?
Your answer should be very brief. -3.42. In the year 1967, what is the difference between the Imports(as % of merchandise exports) of Ghana and Imports(as % of merchandise exports) of United States?
Give a very brief answer. -5.29. In the year 1967, what is the difference between the Imports(as % of merchandise exports) of Ghana and Imports(as % of merchandise exports) of Zambia?
Offer a terse response. -0.1. In the year 1967, what is the difference between the Imports(as % of merchandise exports) of Malta and Imports(as % of merchandise exports) of United States?
Ensure brevity in your answer.  -1.87. In the year 1967, what is the difference between the Imports(as % of merchandise exports) in Malta and Imports(as % of merchandise exports) in Zambia?
Your answer should be very brief. 3.33. In the year 1967, what is the difference between the Imports(as % of merchandise exports) of United States and Imports(as % of merchandise exports) of Zambia?
Your response must be concise. 5.2. In the year 1970, what is the difference between the Imports(as % of merchandise exports) in Ghana and Imports(as % of merchandise exports) in Malta?
Offer a terse response. -1.17. In the year 1970, what is the difference between the Imports(as % of merchandise exports) in Ghana and Imports(as % of merchandise exports) in United States?
Ensure brevity in your answer.  -2.6. In the year 1970, what is the difference between the Imports(as % of merchandise exports) in Ghana and Imports(as % of merchandise exports) in Zambia?
Your response must be concise. 0.87. In the year 1970, what is the difference between the Imports(as % of merchandise exports) of Malta and Imports(as % of merchandise exports) of United States?
Offer a terse response. -1.43. In the year 1970, what is the difference between the Imports(as % of merchandise exports) in Malta and Imports(as % of merchandise exports) in Zambia?
Ensure brevity in your answer.  2.03. In the year 1970, what is the difference between the Imports(as % of merchandise exports) in United States and Imports(as % of merchandise exports) in Zambia?
Your answer should be very brief. 3.47. In the year 1971, what is the difference between the Imports(as % of merchandise exports) in Ghana and Imports(as % of merchandise exports) in Malta?
Your answer should be compact. -0.39. In the year 1971, what is the difference between the Imports(as % of merchandise exports) of Ghana and Imports(as % of merchandise exports) of United States?
Offer a terse response. -2.37. In the year 1971, what is the difference between the Imports(as % of merchandise exports) of Ghana and Imports(as % of merchandise exports) of Zambia?
Provide a succinct answer. 0.8. In the year 1971, what is the difference between the Imports(as % of merchandise exports) of Malta and Imports(as % of merchandise exports) of United States?
Ensure brevity in your answer.  -1.98. In the year 1971, what is the difference between the Imports(as % of merchandise exports) of Malta and Imports(as % of merchandise exports) of Zambia?
Keep it short and to the point. 1.19. In the year 1971, what is the difference between the Imports(as % of merchandise exports) in United States and Imports(as % of merchandise exports) in Zambia?
Provide a succinct answer. 3.16. In the year 1972, what is the difference between the Imports(as % of merchandise exports) of Ghana and Imports(as % of merchandise exports) of Malta?
Provide a short and direct response. 0.77. In the year 1972, what is the difference between the Imports(as % of merchandise exports) in Ghana and Imports(as % of merchandise exports) in United States?
Offer a terse response. -1.73. In the year 1972, what is the difference between the Imports(as % of merchandise exports) of Ghana and Imports(as % of merchandise exports) of Zambia?
Give a very brief answer. 1.67. In the year 1972, what is the difference between the Imports(as % of merchandise exports) of Malta and Imports(as % of merchandise exports) of United States?
Keep it short and to the point. -2.5. In the year 1972, what is the difference between the Imports(as % of merchandise exports) of Malta and Imports(as % of merchandise exports) of Zambia?
Provide a succinct answer. 0.9. In the year 1972, what is the difference between the Imports(as % of merchandise exports) of United States and Imports(as % of merchandise exports) of Zambia?
Your response must be concise. 3.4. In the year 1973, what is the difference between the Imports(as % of merchandise exports) of Ghana and Imports(as % of merchandise exports) of Malta?
Provide a short and direct response. 1.3. In the year 1973, what is the difference between the Imports(as % of merchandise exports) in Ghana and Imports(as % of merchandise exports) in United States?
Offer a terse response. -1.04. In the year 1973, what is the difference between the Imports(as % of merchandise exports) of Ghana and Imports(as % of merchandise exports) of Zambia?
Your response must be concise. 2.74. In the year 1973, what is the difference between the Imports(as % of merchandise exports) in Malta and Imports(as % of merchandise exports) in United States?
Give a very brief answer. -2.34. In the year 1973, what is the difference between the Imports(as % of merchandise exports) in Malta and Imports(as % of merchandise exports) in Zambia?
Your answer should be very brief. 1.44. In the year 1973, what is the difference between the Imports(as % of merchandise exports) of United States and Imports(as % of merchandise exports) of Zambia?
Your answer should be very brief. 3.78. In the year 1974, what is the difference between the Imports(as % of merchandise exports) in Ghana and Imports(as % of merchandise exports) in Malta?
Make the answer very short. 0.22. In the year 1974, what is the difference between the Imports(as % of merchandise exports) in Ghana and Imports(as % of merchandise exports) in United States?
Provide a succinct answer. -1.18. In the year 1974, what is the difference between the Imports(as % of merchandise exports) in Ghana and Imports(as % of merchandise exports) in Zambia?
Give a very brief answer. 0.83. In the year 1974, what is the difference between the Imports(as % of merchandise exports) of Malta and Imports(as % of merchandise exports) of United States?
Keep it short and to the point. -1.4. In the year 1974, what is the difference between the Imports(as % of merchandise exports) of Malta and Imports(as % of merchandise exports) of Zambia?
Your response must be concise. 0.6. In the year 1974, what is the difference between the Imports(as % of merchandise exports) of United States and Imports(as % of merchandise exports) of Zambia?
Offer a very short reply. 2.01. In the year 1975, what is the difference between the Imports(as % of merchandise exports) of Ghana and Imports(as % of merchandise exports) of Malta?
Ensure brevity in your answer.  0.86. In the year 1975, what is the difference between the Imports(as % of merchandise exports) of Ghana and Imports(as % of merchandise exports) of United States?
Your response must be concise. -0.81. In the year 1975, what is the difference between the Imports(as % of merchandise exports) of Ghana and Imports(as % of merchandise exports) of Zambia?
Provide a succinct answer. 1.05. In the year 1975, what is the difference between the Imports(as % of merchandise exports) of Malta and Imports(as % of merchandise exports) of United States?
Your response must be concise. -1.67. In the year 1975, what is the difference between the Imports(as % of merchandise exports) of Malta and Imports(as % of merchandise exports) of Zambia?
Ensure brevity in your answer.  0.19. In the year 1975, what is the difference between the Imports(as % of merchandise exports) in United States and Imports(as % of merchandise exports) in Zambia?
Provide a succinct answer. 1.86. What is the ratio of the Imports(as % of merchandise exports) of Ghana in 1966 to that in 1967?
Provide a short and direct response. 0.59. What is the ratio of the Imports(as % of merchandise exports) in Malta in 1966 to that in 1967?
Your response must be concise. 1.36. What is the ratio of the Imports(as % of merchandise exports) of United States in 1966 to that in 1967?
Keep it short and to the point. 1.21. What is the ratio of the Imports(as % of merchandise exports) of Zambia in 1966 to that in 1967?
Your answer should be compact. 1.22. What is the ratio of the Imports(as % of merchandise exports) in Ghana in 1966 to that in 1970?
Provide a succinct answer. 0.27. What is the ratio of the Imports(as % of merchandise exports) in Malta in 1966 to that in 1970?
Your answer should be very brief. 1.87. What is the ratio of the Imports(as % of merchandise exports) of United States in 1966 to that in 1970?
Give a very brief answer. 1.63. What is the ratio of the Imports(as % of merchandise exports) of Zambia in 1966 to that in 1970?
Make the answer very short. 1.1. What is the ratio of the Imports(as % of merchandise exports) in Ghana in 1966 to that in 1971?
Your answer should be compact. 0.26. What is the ratio of the Imports(as % of merchandise exports) in Malta in 1966 to that in 1971?
Your answer should be compact. 2.41. What is the ratio of the Imports(as % of merchandise exports) of United States in 1966 to that in 1971?
Your response must be concise. 1.69. What is the ratio of the Imports(as % of merchandise exports) in Zambia in 1966 to that in 1971?
Offer a terse response. 0.97. What is the ratio of the Imports(as % of merchandise exports) of Ghana in 1966 to that in 1972?
Offer a very short reply. 0.19. What is the ratio of the Imports(as % of merchandise exports) of Malta in 1966 to that in 1972?
Provide a succinct answer. 2.94. What is the ratio of the Imports(as % of merchandise exports) of United States in 1966 to that in 1972?
Provide a succinct answer. 1.66. What is the ratio of the Imports(as % of merchandise exports) in Zambia in 1966 to that in 1972?
Your answer should be compact. 1.11. What is the ratio of the Imports(as % of merchandise exports) in Ghana in 1966 to that in 1973?
Your answer should be compact. 0.14. What is the ratio of the Imports(as % of merchandise exports) in Malta in 1966 to that in 1973?
Give a very brief answer. 2.45. What is the ratio of the Imports(as % of merchandise exports) in United States in 1966 to that in 1973?
Ensure brevity in your answer.  1.58. What is the ratio of the Imports(as % of merchandise exports) of Zambia in 1966 to that in 1973?
Offer a terse response. 1.28. What is the ratio of the Imports(as % of merchandise exports) of Ghana in 1966 to that in 1974?
Make the answer very short. 0.22. What is the ratio of the Imports(as % of merchandise exports) in Malta in 1966 to that in 1974?
Your response must be concise. 2.73. What is the ratio of the Imports(as % of merchandise exports) in United States in 1966 to that in 1974?
Ensure brevity in your answer.  2.1. What is the ratio of the Imports(as % of merchandise exports) in Zambia in 1966 to that in 1974?
Offer a terse response. 0.79. What is the ratio of the Imports(as % of merchandise exports) in Ghana in 1966 to that in 1975?
Your response must be concise. 0.23. What is the ratio of the Imports(as % of merchandise exports) in Malta in 1966 to that in 1975?
Your response must be concise. 4.17. What is the ratio of the Imports(as % of merchandise exports) of United States in 1966 to that in 1975?
Keep it short and to the point. 2.43. What is the ratio of the Imports(as % of merchandise exports) in Zambia in 1966 to that in 1975?
Your answer should be compact. 1. What is the ratio of the Imports(as % of merchandise exports) of Ghana in 1967 to that in 1970?
Your answer should be compact. 0.46. What is the ratio of the Imports(as % of merchandise exports) in Malta in 1967 to that in 1970?
Offer a very short reply. 1.38. What is the ratio of the Imports(as % of merchandise exports) in United States in 1967 to that in 1970?
Your answer should be compact. 1.36. What is the ratio of the Imports(as % of merchandise exports) in Zambia in 1967 to that in 1970?
Your answer should be very brief. 0.9. What is the ratio of the Imports(as % of merchandise exports) in Ghana in 1967 to that in 1971?
Offer a terse response. 0.44. What is the ratio of the Imports(as % of merchandise exports) in Malta in 1967 to that in 1971?
Give a very brief answer. 1.77. What is the ratio of the Imports(as % of merchandise exports) in United States in 1967 to that in 1971?
Provide a succinct answer. 1.4. What is the ratio of the Imports(as % of merchandise exports) of Zambia in 1967 to that in 1971?
Provide a succinct answer. 0.8. What is the ratio of the Imports(as % of merchandise exports) of Ghana in 1967 to that in 1972?
Keep it short and to the point. 0.33. What is the ratio of the Imports(as % of merchandise exports) in Malta in 1967 to that in 1972?
Provide a short and direct response. 2.17. What is the ratio of the Imports(as % of merchandise exports) of United States in 1967 to that in 1972?
Offer a very short reply. 1.38. What is the ratio of the Imports(as % of merchandise exports) in Zambia in 1967 to that in 1972?
Your response must be concise. 0.91. What is the ratio of the Imports(as % of merchandise exports) in Ghana in 1967 to that in 1973?
Offer a very short reply. 0.24. What is the ratio of the Imports(as % of merchandise exports) of Malta in 1967 to that in 1973?
Make the answer very short. 1.8. What is the ratio of the Imports(as % of merchandise exports) in United States in 1967 to that in 1973?
Give a very brief answer. 1.31. What is the ratio of the Imports(as % of merchandise exports) of Zambia in 1967 to that in 1973?
Your answer should be very brief. 1.04. What is the ratio of the Imports(as % of merchandise exports) of Ghana in 1967 to that in 1974?
Offer a very short reply. 0.38. What is the ratio of the Imports(as % of merchandise exports) in Malta in 1967 to that in 1974?
Offer a terse response. 2.01. What is the ratio of the Imports(as % of merchandise exports) in United States in 1967 to that in 1974?
Provide a succinct answer. 1.74. What is the ratio of the Imports(as % of merchandise exports) in Zambia in 1967 to that in 1974?
Your answer should be compact. 0.65. What is the ratio of the Imports(as % of merchandise exports) in Ghana in 1967 to that in 1975?
Your answer should be compact. 0.4. What is the ratio of the Imports(as % of merchandise exports) of Malta in 1967 to that in 1975?
Give a very brief answer. 3.07. What is the ratio of the Imports(as % of merchandise exports) in United States in 1967 to that in 1975?
Your answer should be compact. 2.01. What is the ratio of the Imports(as % of merchandise exports) of Zambia in 1967 to that in 1975?
Your answer should be compact. 0.82. What is the ratio of the Imports(as % of merchandise exports) of Ghana in 1970 to that in 1971?
Provide a succinct answer. 0.96. What is the ratio of the Imports(as % of merchandise exports) of Malta in 1970 to that in 1971?
Your response must be concise. 1.29. What is the ratio of the Imports(as % of merchandise exports) of United States in 1970 to that in 1971?
Make the answer very short. 1.04. What is the ratio of the Imports(as % of merchandise exports) of Zambia in 1970 to that in 1971?
Ensure brevity in your answer.  0.88. What is the ratio of the Imports(as % of merchandise exports) of Ghana in 1970 to that in 1972?
Offer a terse response. 0.71. What is the ratio of the Imports(as % of merchandise exports) in Malta in 1970 to that in 1972?
Give a very brief answer. 1.57. What is the ratio of the Imports(as % of merchandise exports) of United States in 1970 to that in 1972?
Your answer should be compact. 1.02. What is the ratio of the Imports(as % of merchandise exports) of Zambia in 1970 to that in 1972?
Offer a terse response. 1.01. What is the ratio of the Imports(as % of merchandise exports) of Ghana in 1970 to that in 1973?
Make the answer very short. 0.53. What is the ratio of the Imports(as % of merchandise exports) in Malta in 1970 to that in 1973?
Offer a terse response. 1.31. What is the ratio of the Imports(as % of merchandise exports) in United States in 1970 to that in 1973?
Offer a terse response. 0.97. What is the ratio of the Imports(as % of merchandise exports) of Zambia in 1970 to that in 1973?
Provide a short and direct response. 1.16. What is the ratio of the Imports(as % of merchandise exports) in Ghana in 1970 to that in 1974?
Offer a very short reply. 0.83. What is the ratio of the Imports(as % of merchandise exports) in Malta in 1970 to that in 1974?
Keep it short and to the point. 1.46. What is the ratio of the Imports(as % of merchandise exports) in United States in 1970 to that in 1974?
Provide a short and direct response. 1.29. What is the ratio of the Imports(as % of merchandise exports) in Zambia in 1970 to that in 1974?
Provide a short and direct response. 0.72. What is the ratio of the Imports(as % of merchandise exports) of Ghana in 1970 to that in 1975?
Your answer should be compact. 0.87. What is the ratio of the Imports(as % of merchandise exports) in Malta in 1970 to that in 1975?
Offer a very short reply. 2.23. What is the ratio of the Imports(as % of merchandise exports) in United States in 1970 to that in 1975?
Your answer should be compact. 1.49. What is the ratio of the Imports(as % of merchandise exports) of Zambia in 1970 to that in 1975?
Provide a succinct answer. 0.91. What is the ratio of the Imports(as % of merchandise exports) of Ghana in 1971 to that in 1972?
Give a very brief answer. 0.74. What is the ratio of the Imports(as % of merchandise exports) in Malta in 1971 to that in 1972?
Offer a terse response. 1.22. What is the ratio of the Imports(as % of merchandise exports) in United States in 1971 to that in 1972?
Make the answer very short. 0.98. What is the ratio of the Imports(as % of merchandise exports) in Zambia in 1971 to that in 1972?
Offer a very short reply. 1.14. What is the ratio of the Imports(as % of merchandise exports) of Ghana in 1971 to that in 1973?
Keep it short and to the point. 0.55. What is the ratio of the Imports(as % of merchandise exports) in Malta in 1971 to that in 1973?
Make the answer very short. 1.02. What is the ratio of the Imports(as % of merchandise exports) of United States in 1971 to that in 1973?
Provide a short and direct response. 0.93. What is the ratio of the Imports(as % of merchandise exports) of Zambia in 1971 to that in 1973?
Your answer should be very brief. 1.31. What is the ratio of the Imports(as % of merchandise exports) of Ghana in 1971 to that in 1974?
Provide a succinct answer. 0.86. What is the ratio of the Imports(as % of merchandise exports) of Malta in 1971 to that in 1974?
Provide a short and direct response. 1.14. What is the ratio of the Imports(as % of merchandise exports) of United States in 1971 to that in 1974?
Give a very brief answer. 1.24. What is the ratio of the Imports(as % of merchandise exports) of Zambia in 1971 to that in 1974?
Provide a short and direct response. 0.81. What is the ratio of the Imports(as % of merchandise exports) in Ghana in 1971 to that in 1975?
Offer a very short reply. 0.9. What is the ratio of the Imports(as % of merchandise exports) in Malta in 1971 to that in 1975?
Provide a succinct answer. 1.73. What is the ratio of the Imports(as % of merchandise exports) in United States in 1971 to that in 1975?
Make the answer very short. 1.43. What is the ratio of the Imports(as % of merchandise exports) in Zambia in 1971 to that in 1975?
Your response must be concise. 1.03. What is the ratio of the Imports(as % of merchandise exports) of Ghana in 1972 to that in 1973?
Offer a terse response. 0.75. What is the ratio of the Imports(as % of merchandise exports) of Malta in 1972 to that in 1973?
Provide a short and direct response. 0.83. What is the ratio of the Imports(as % of merchandise exports) of United States in 1972 to that in 1973?
Keep it short and to the point. 0.95. What is the ratio of the Imports(as % of merchandise exports) in Zambia in 1972 to that in 1973?
Offer a terse response. 1.15. What is the ratio of the Imports(as % of merchandise exports) of Ghana in 1972 to that in 1974?
Ensure brevity in your answer.  1.17. What is the ratio of the Imports(as % of merchandise exports) in Malta in 1972 to that in 1974?
Offer a very short reply. 0.93. What is the ratio of the Imports(as % of merchandise exports) of United States in 1972 to that in 1974?
Offer a very short reply. 1.27. What is the ratio of the Imports(as % of merchandise exports) of Zambia in 1972 to that in 1974?
Give a very brief answer. 0.71. What is the ratio of the Imports(as % of merchandise exports) of Ghana in 1972 to that in 1975?
Offer a very short reply. 1.22. What is the ratio of the Imports(as % of merchandise exports) of Malta in 1972 to that in 1975?
Make the answer very short. 1.42. What is the ratio of the Imports(as % of merchandise exports) of United States in 1972 to that in 1975?
Give a very brief answer. 1.46. What is the ratio of the Imports(as % of merchandise exports) of Zambia in 1972 to that in 1975?
Keep it short and to the point. 0.9. What is the ratio of the Imports(as % of merchandise exports) of Ghana in 1973 to that in 1974?
Ensure brevity in your answer.  1.56. What is the ratio of the Imports(as % of merchandise exports) of Malta in 1973 to that in 1974?
Offer a terse response. 1.12. What is the ratio of the Imports(as % of merchandise exports) of United States in 1973 to that in 1974?
Provide a succinct answer. 1.33. What is the ratio of the Imports(as % of merchandise exports) of Zambia in 1973 to that in 1974?
Your answer should be very brief. 0.62. What is the ratio of the Imports(as % of merchandise exports) of Ghana in 1973 to that in 1975?
Your response must be concise. 1.63. What is the ratio of the Imports(as % of merchandise exports) in Malta in 1973 to that in 1975?
Make the answer very short. 1.7. What is the ratio of the Imports(as % of merchandise exports) in United States in 1973 to that in 1975?
Make the answer very short. 1.54. What is the ratio of the Imports(as % of merchandise exports) in Zambia in 1973 to that in 1975?
Your answer should be very brief. 0.78. What is the ratio of the Imports(as % of merchandise exports) in Ghana in 1974 to that in 1975?
Provide a short and direct response. 1.05. What is the ratio of the Imports(as % of merchandise exports) of Malta in 1974 to that in 1975?
Provide a succinct answer. 1.52. What is the ratio of the Imports(as % of merchandise exports) in United States in 1974 to that in 1975?
Keep it short and to the point. 1.15. What is the ratio of the Imports(as % of merchandise exports) of Zambia in 1974 to that in 1975?
Provide a short and direct response. 1.26. What is the difference between the highest and the second highest Imports(as % of merchandise exports) in Ghana?
Ensure brevity in your answer.  0.93. What is the difference between the highest and the second highest Imports(as % of merchandise exports) of Malta?
Offer a terse response. 1.55. What is the difference between the highest and the second highest Imports(as % of merchandise exports) in United States?
Ensure brevity in your answer.  1.27. What is the difference between the highest and the second highest Imports(as % of merchandise exports) of Zambia?
Make the answer very short. 0.29. What is the difference between the highest and the lowest Imports(as % of merchandise exports) in Ghana?
Offer a terse response. 3.17. What is the difference between the highest and the lowest Imports(as % of merchandise exports) in Malta?
Your answer should be very brief. 4.47. What is the difference between the highest and the lowest Imports(as % of merchandise exports) of United States?
Provide a short and direct response. 4.39. What is the difference between the highest and the lowest Imports(as % of merchandise exports) of Zambia?
Make the answer very short. 0.59. 